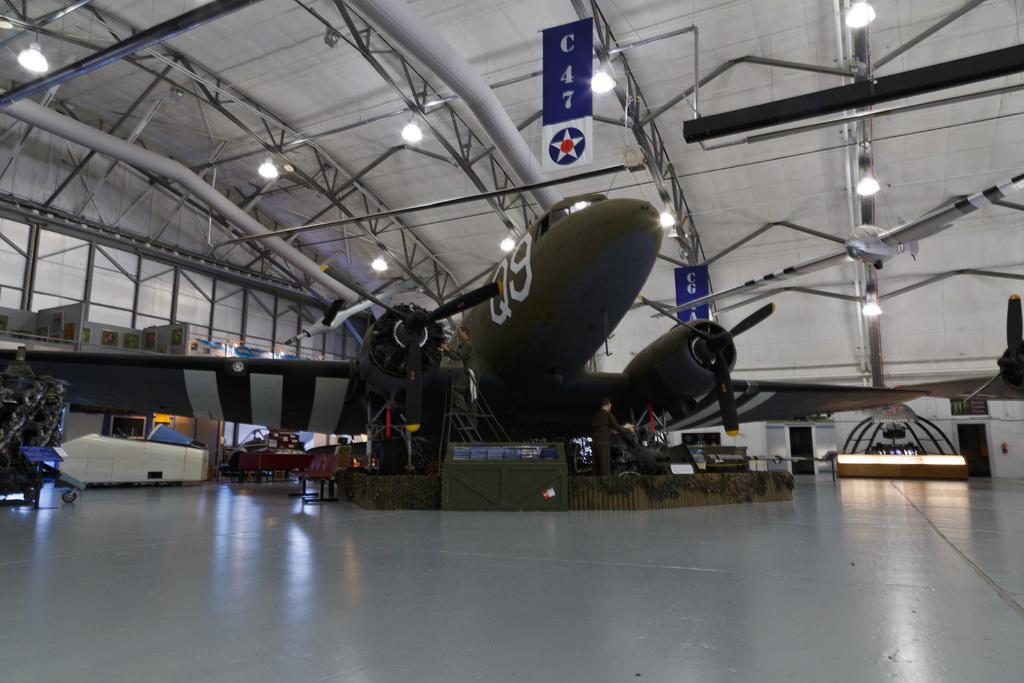Can you describe this image briefly? In this picture we can see an airplane in the middle, on the left side there are chairs, we can see two boards, metal rods and lights at the top of the picture, on the right side we can see another aircraft. 